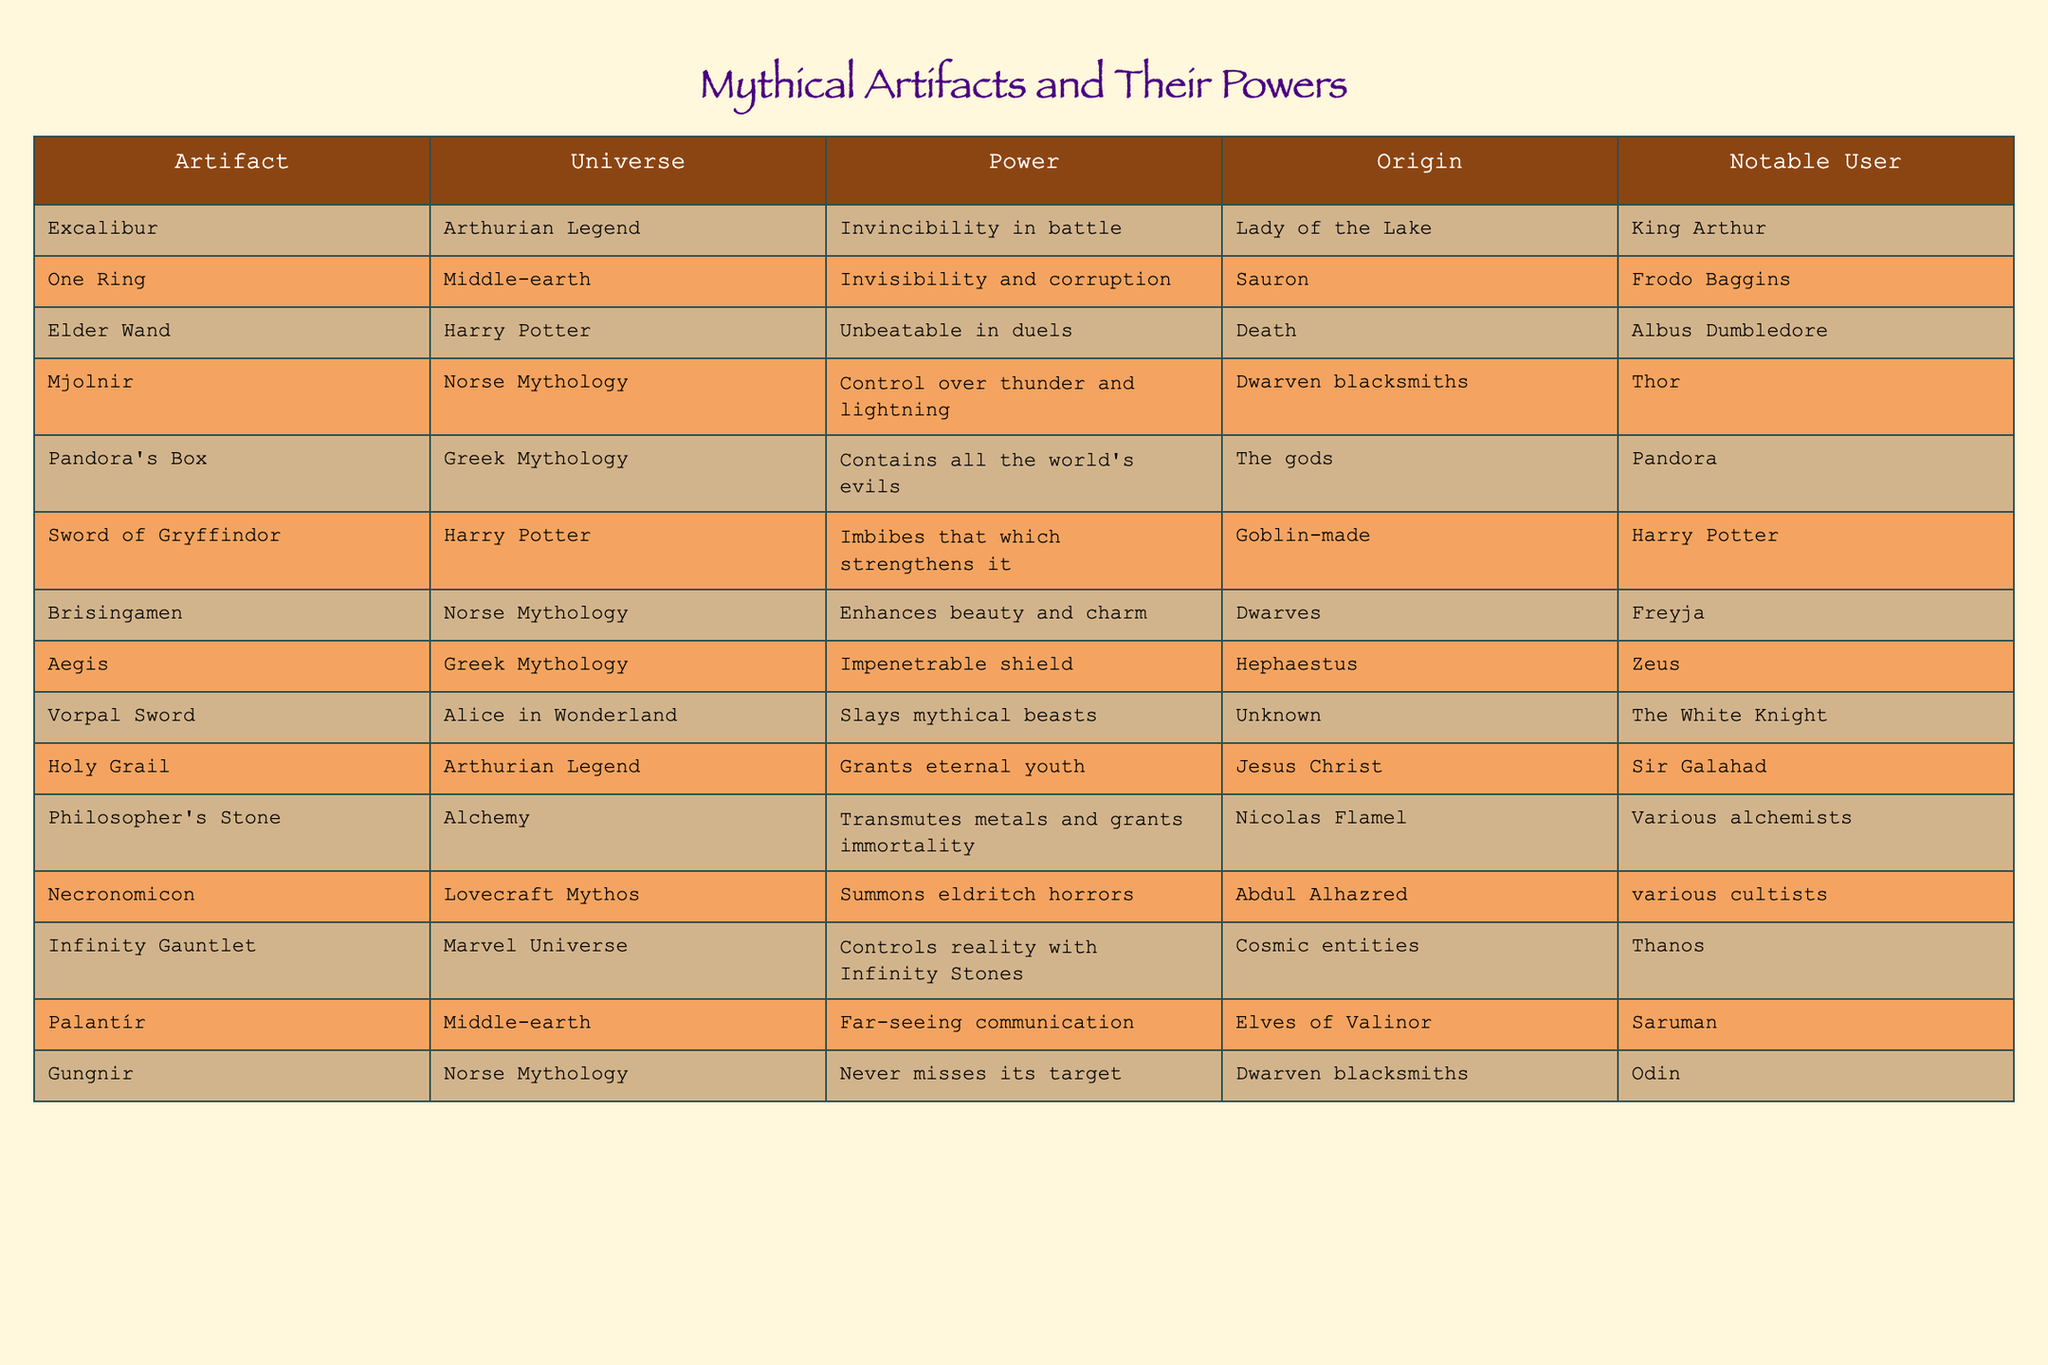What power does the One Ring provide? The table clearly states that the One Ring grants the power of invisibility and corruption.
Answer: Invisibility and corruption Who forged Mjolnir? According to the table, Mjolnir was forged by dwarven blacksmiths.
Answer: Dwarven blacksmiths Which artifact is known to enhance beauty and charm? The table specifies that Brisingamen enhances beauty and charm.
Answer: Brisingamen Is the Holy Grail associated with eternal youth? The table indicates that the Holy Grail grants eternal youth, which means the statement is true.
Answer: True What is the notable user of the Elder Wand? The table shows that the notable user of the Elder Wand is Albus Dumbledore.
Answer: Albus Dumbledore How many artifacts in Norse Mythology are listed in the table? The table contains three artifacts from Norse Mythology: Mjolnir, Brisingamen, and Gungnir. Therefore, there are three artifacts.
Answer: 3 Which artifact is said to summon eldritch horrors? As per the table, the Necronomicon is the artifact that summons eldritch horrors.
Answer: Necronomicon What is the difference in power between the Sword of Gryffindor and Excalibur? The Sword of Gryffindor imbibes what strengthens it, while Excalibur grants invincibility in battle, indicating they have different powers without direct mathematical comparison.
Answer: Different powers Which artifacts were created by dwarven blacksmiths? The table lists Mjolnir and Gungnir as artifacts created by dwarven blacksmiths.
Answer: Mjolnir and Gungnir Can the Infinity Gauntlet control reality with Infinity Stones? Yes, the table confirms that the Infinity Gauntlet has the power to control reality with Infinity Stones.
Answer: Yes In which universe is Pandora's Box found? According to the table, Pandora's Box is found in Greek Mythology.
Answer: Greek Mythology What are the powers of artifacts associated with the Arthurian Legend? The powers listed for the artifacts in the Arthurian Legend are invincibility in battle for Excalibur and eternal youth for the Holy Grail.
Answer: Invincibility in battle and eternal youth What is the notable user of the One Ring, and what power does it give? The table shows that the notable user of the One Ring is Frodo Baggins and the power it gives is invisibility and corruption.
Answer: Frodo Baggins; invisibility and corruption 